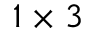<formula> <loc_0><loc_0><loc_500><loc_500>1 \times 3</formula> 